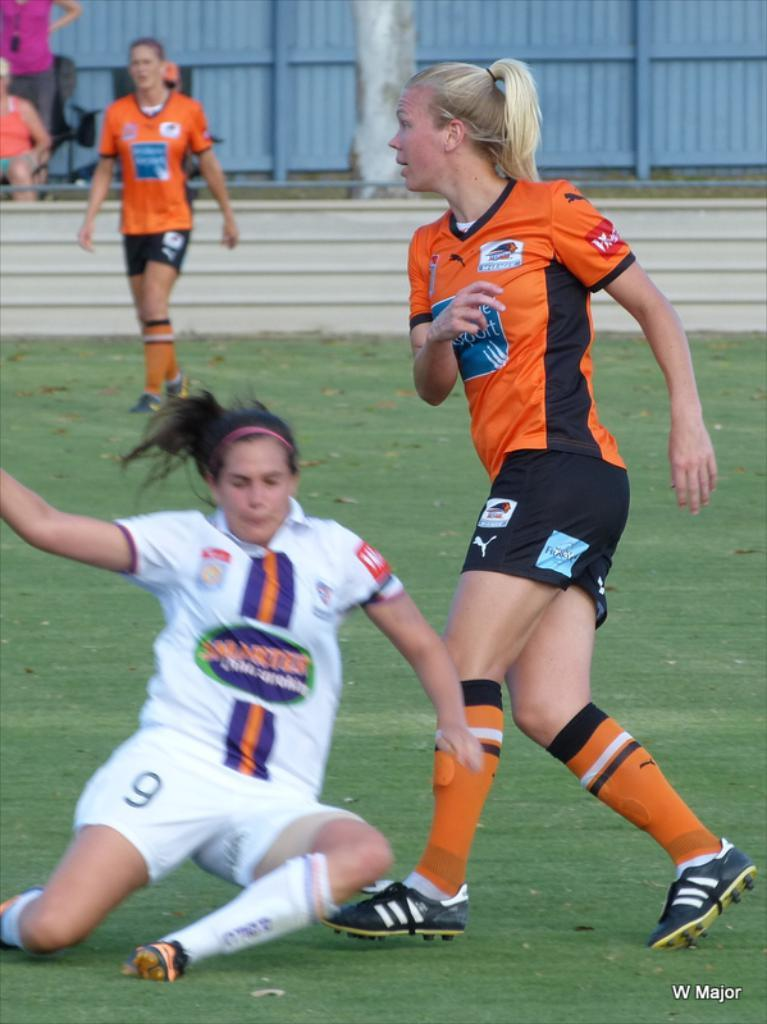<image>
Present a compact description of the photo's key features. Soccer players wearing puma shorts and adidas shoes colliding with one another. 